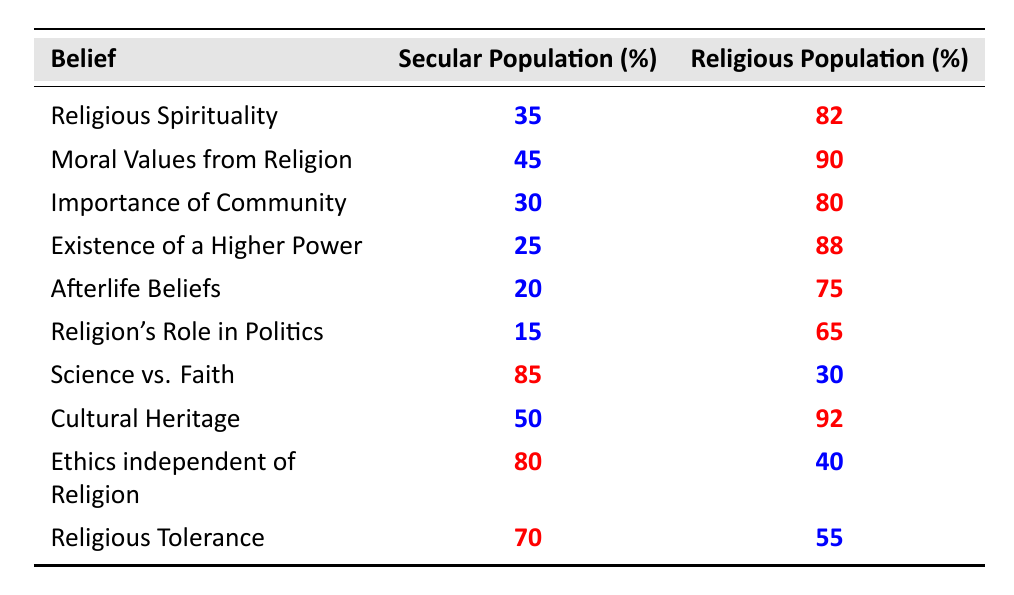What percentage of the secular population believes in the existence of a higher power? From the table, the percentage for the secular population regarding the belief in the existence of a higher power is clearly stated as 25.
Answer: 25 What is the difference in the percentage of the belief in moral values from religion between the secular and religious populations? To find the difference, subtract the secular percentage from the religious percentage: 90 - 45 = 45.
Answer: 45 Is the belief that science and faith can coexist more prevalent among the secular or the religious population? The table indicates that 85% of the secular population believes this, while only 30% of the religious population does, so it is more prevalent among the secular population.
Answer: Secular population What percentage of the religious population supports the idea of ethics being independent of religion? The table shows that 40% of the religious population supports this idea.
Answer: 40 What is the average percentage belief in religious spirituality and afterlife beliefs among the secular population? To calculate the average, add the secular percentages for both beliefs: 35 + 20 = 55, then divide by 2 (there are 2 beliefs), so the average is 55/2 = 27.5.
Answer: 27.5 Which belief has the highest percentage among the secular population, and what is that percentage? The belief with the highest percentage among the secular population is "Science vs. Faith," with a percentage of 85.
Answer: 85 How many beliefs are there in total listed for the secular population? There are ten beliefs listed in the table for the secular population.
Answer: 10 Is it true that a higher percentage of the religious population believes in afterlife beliefs compared to secular beliefs? Yes, the religious population has a 75% belief in afterlife beliefs, while the secular population only has 20%, confirming that the religious population indeed has a higher belief.
Answer: Yes What is the least prevalent belief among the secular population, and what is its percentage? The least prevalent belief among the secular population is "Religion's Role in Politics," with a percentage of 15.
Answer: 15 If the secular population's belief in the importance of community were to increase by 10%, what would the new percentage be? The current percentage for the secular population regarding the importance of community is 30. If this were to increase by 10%, the new percentage would be 30 + 10 = 40.
Answer: 40 